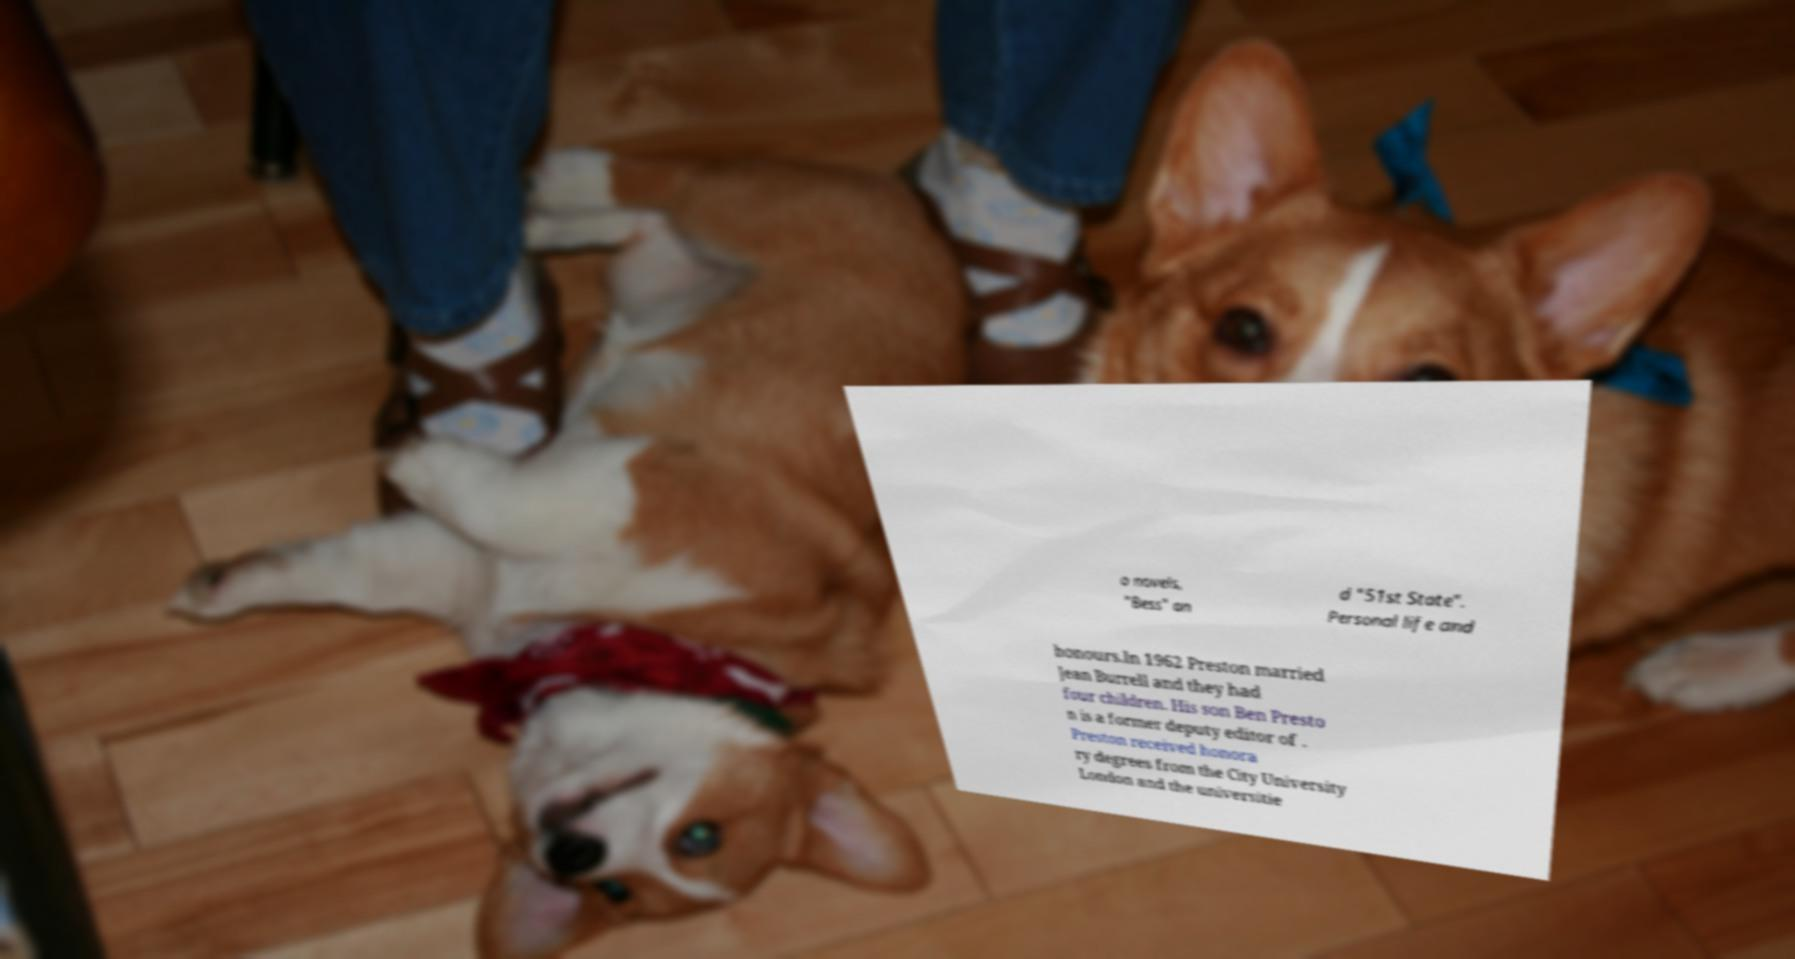Could you extract and type out the text from this image? o novels, "Bess" an d "51st State". Personal life and honours.In 1962 Preston married Jean Burrell and they had four children. His son Ben Presto n is a former deputy editor of . Preston received honora ry degrees from the City University London and the universitie 